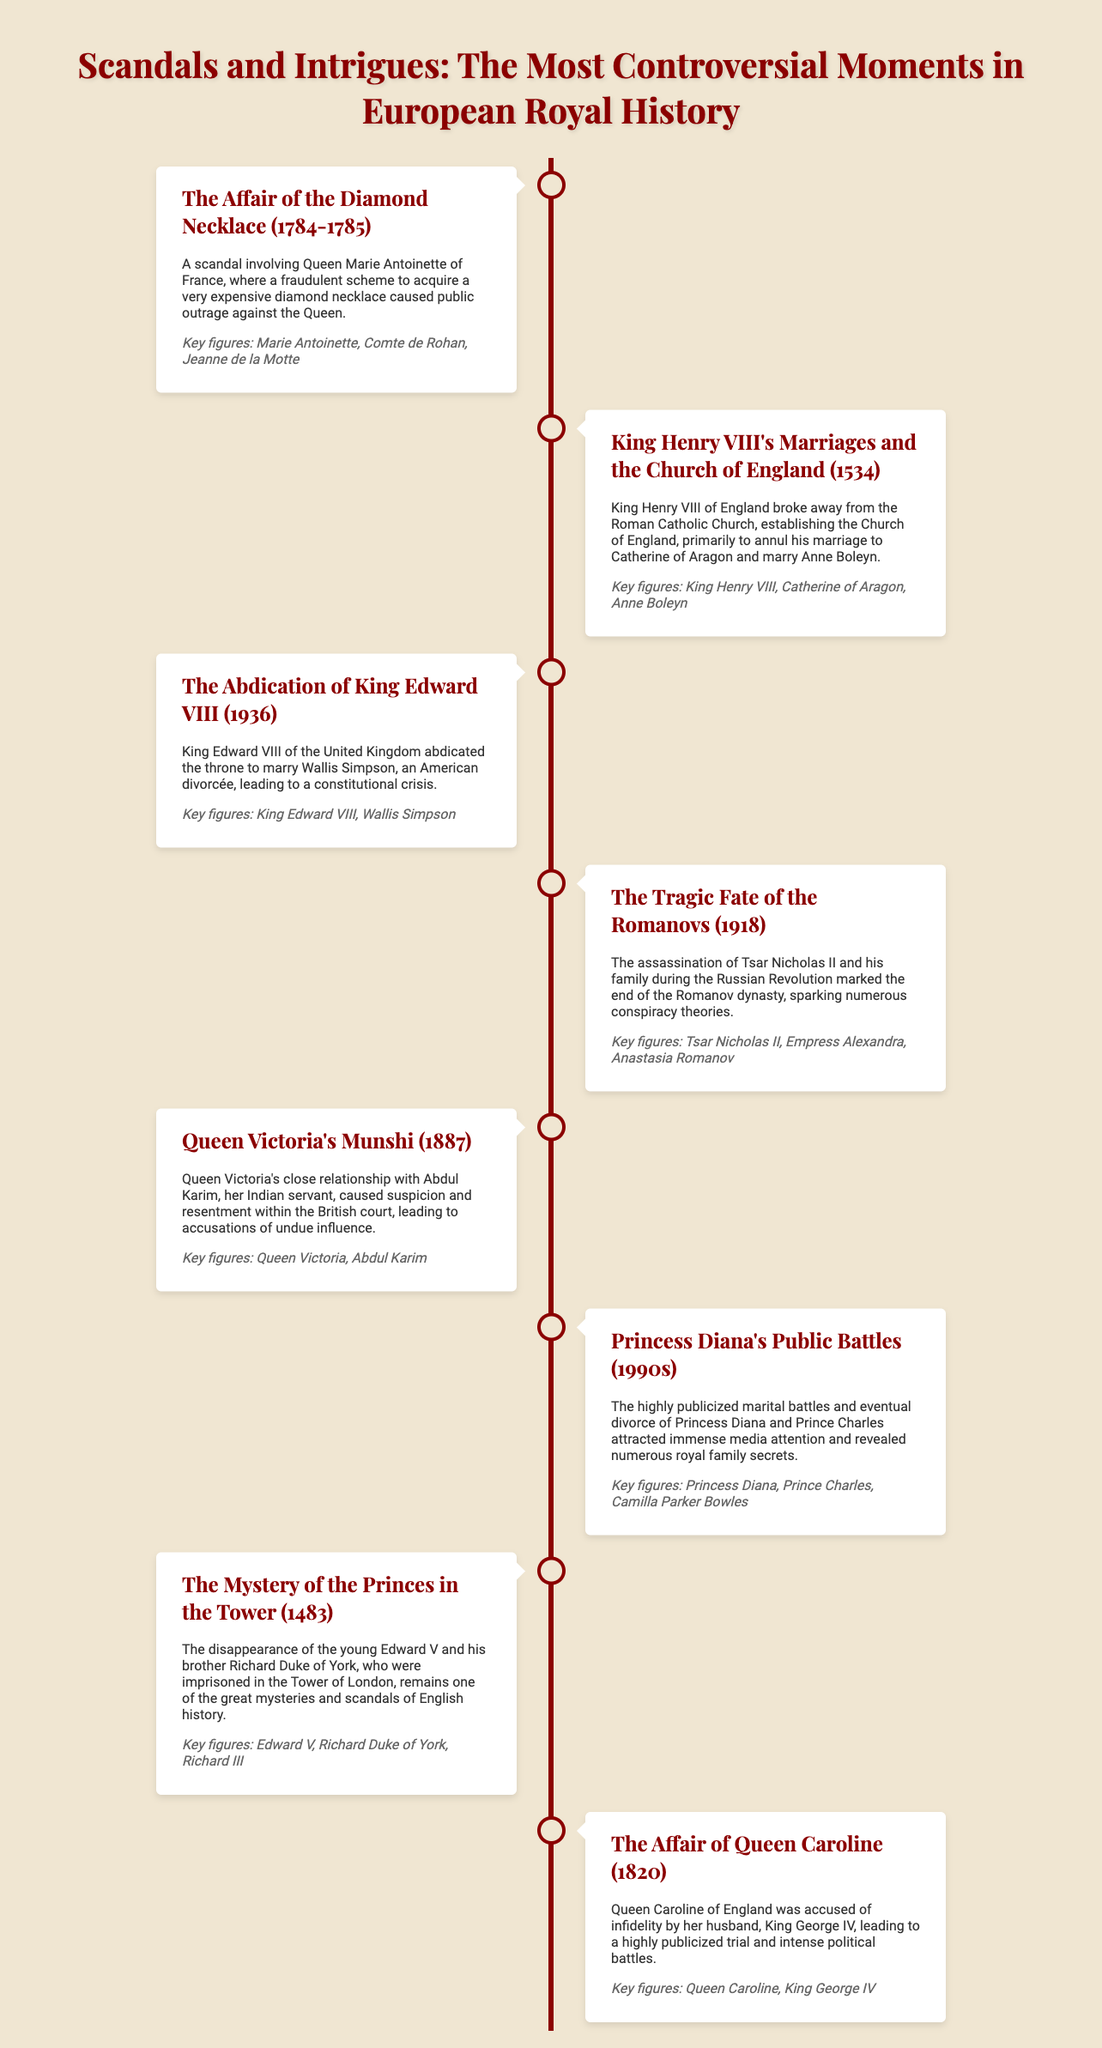What was the scandal involving Marie Antoinette? The scandal known as "The Affair of the Diamond Necklace" involved Queen Marie Antoinette of France and a fraudulent scheme to acquire a very expensive diamond necklace.
Answer: The Affair of the Diamond Necklace Who broke away from the Roman Catholic Church? King Henry VIII of England broke away from the Roman Catholic Church, establishing the Church of England.
Answer: King Henry VIII What year did King Edward VIII abdicate the throne? King Edward VIII abdicated the throne in the year 1936 to marry Wallis Simpson.
Answer: 1936 What event marked the end of the Romanov dynasty? The assassination of Tsar Nicholas II and his family during the Russian Revolution marked the end of the Romanov dynasty.
Answer: The assassination of Tsar Nicholas II Who was accused of infidelity leading to a highly publicized trial? Queen Caroline of England was accused of infidelity by her husband, King George IV, leading to a highly publicized trial.
Answer: Queen Caroline What relationship caused suspicion within the British court? Queen Victoria's close relationship with Abdul Karim, her Indian servant, caused suspicion and resentment within the British court.
Answer: Abdul Karim Which royal figure's marital battles attracted media attention in the 1990s? The marital battles and eventual divorce of Princess Diana and Prince Charles attracted immense media attention.
Answer: Princess Diana Which historical mystery involves Edward V and Richard Duke of York? The mystery of the disappearance of the young Edward V and his brother Richard Duke of York involves their imprisonment in the Tower of London.
Answer: The Princes in the Tower 